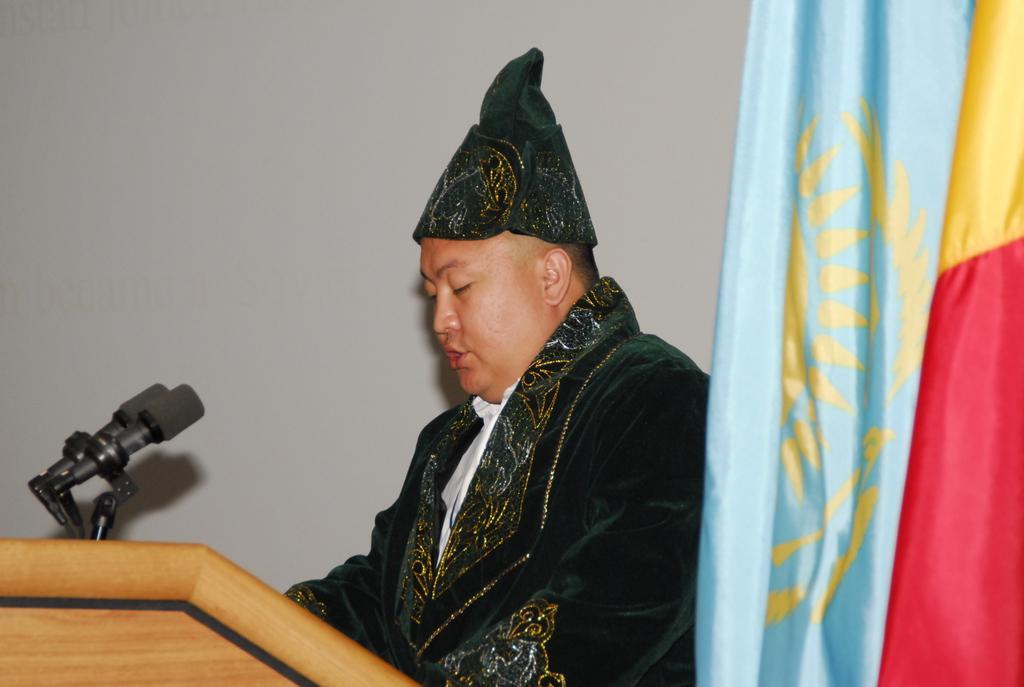Please provide a concise description of this image. In this picture, we see a man is standing. In front of him, we see a podium on which the microphones are placed. I think he is talking on the microphone. On the right side, we see a flag or a cloth in blue, red and yellow color. In the background, we see a wall in white color. 